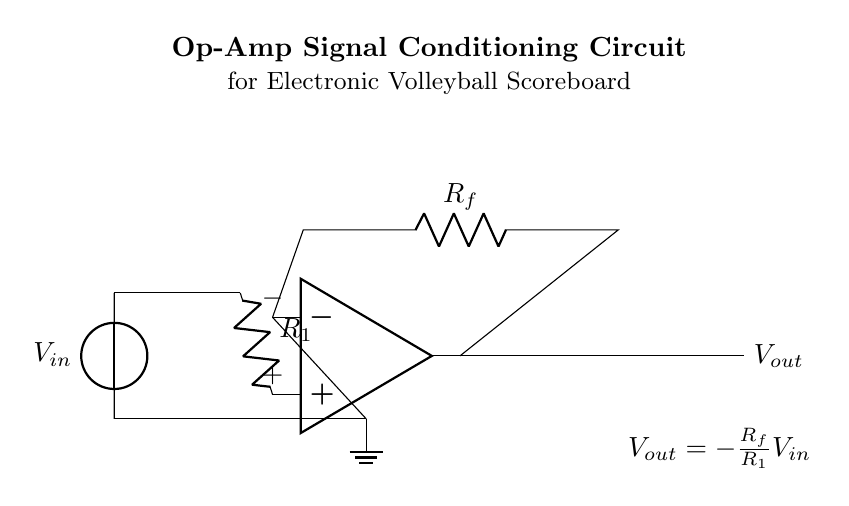What is the input voltage in the circuit? The input voltage is denoted as V_in in the diagram. It is indicated by the voltage source symbol on the left side of the circuit.
Answer: V_in What is the role of R1 in this circuit? R1 is the resistor connected to the non-inverting input of the operational amplifier and it is part of the input signal path, influencing the gain of the circuit.
Answer: Input resistor What is the output voltage equation for this circuit? The output voltage is defined by the equation shown below the op-amp. It states that V_out is negative of the ratio of R_f to R_1 multiplied by V_in, indicating the inversion and gain provided by the circuit.
Answer: V_out = -R_f/R_1 * V_in How does changing R_f affect V_out? Increasing R_f will increase the magnitude of V_out since it is in the numerator of the gain equation, making V_out more negative (or less positive if R_f is decreased) for a given V_in.
Answer: Increases V_out magnitude What is the function of the operational amplifier in this circuit? The operational amplifier amplifies the input signal based on the feedback and the resistors used, which conditions the original signal for further processing in the electronic scoreboard.
Answer: Signal amplification What type of circuit configuration is this? This circuit is configured as an inverting amplifier, as indicated by the feedback connection to the inverting input and the output being taken from the op-amp's output.
Answer: Inverting amplifier 